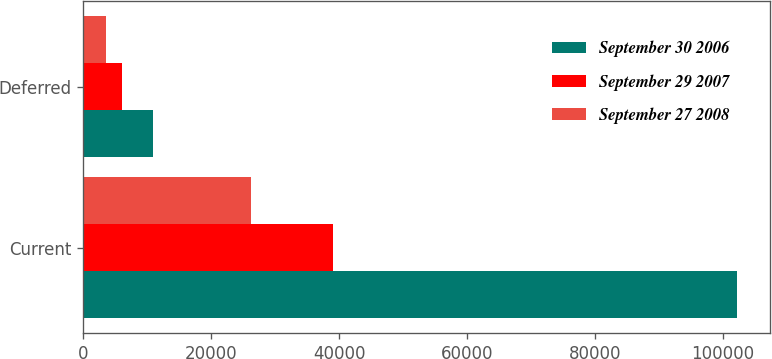<chart> <loc_0><loc_0><loc_500><loc_500><stacked_bar_chart><ecel><fcel>Current<fcel>Deferred<nl><fcel>September 30 2006<fcel>102212<fcel>10835<nl><fcel>September 29 2007<fcel>39096<fcel>6053<nl><fcel>September 27 2008<fcel>26164<fcel>3540<nl></chart> 